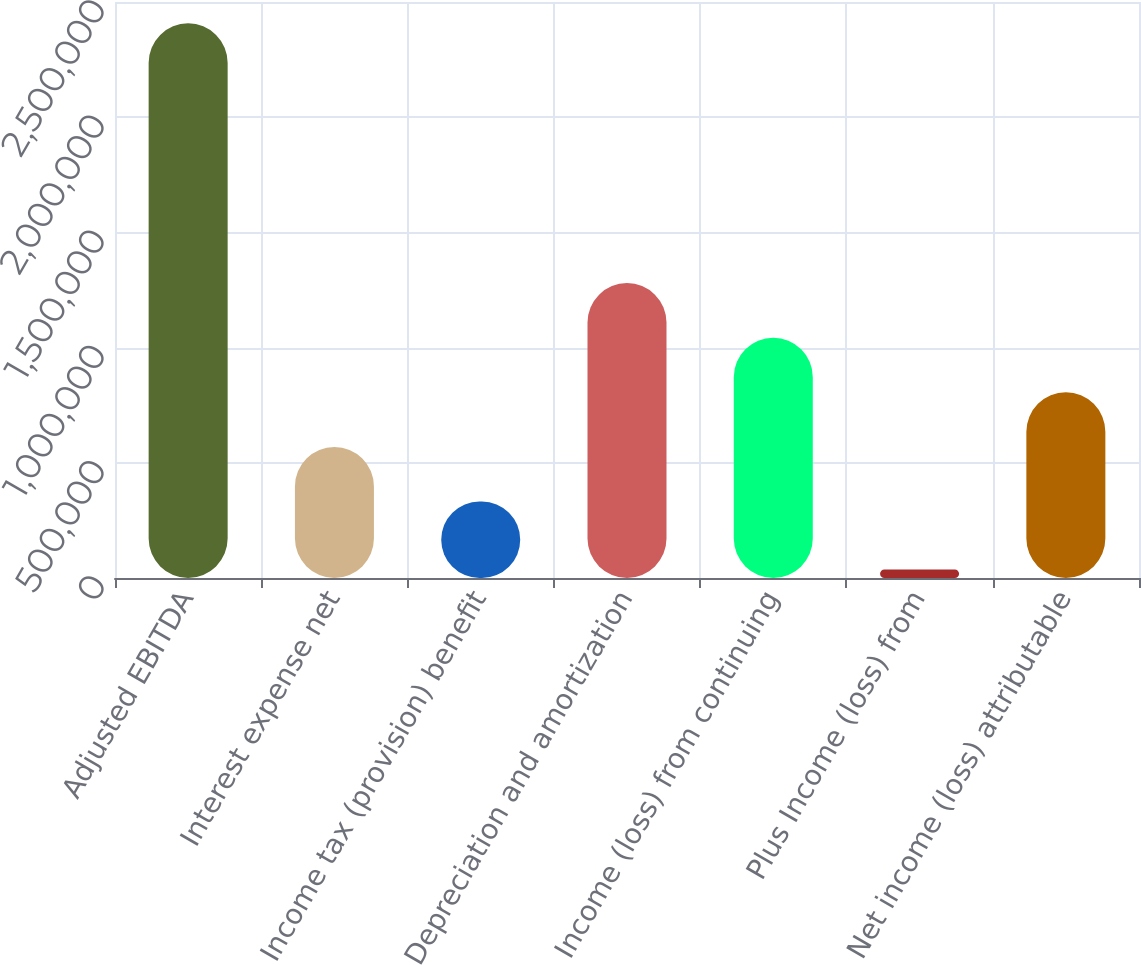<chart> <loc_0><loc_0><loc_500><loc_500><bar_chart><fcel>Adjusted EBITDA<fcel>Interest expense net<fcel>Income tax (provision) benefit<fcel>Depreciation and amortization<fcel>Income (loss) from continuing<fcel>Plus Income (loss) from<fcel>Net income (loss) attributable<nl><fcel>2.40749e+06<fcel>569022<fcel>331991<fcel>1.28011e+06<fcel>1.04308e+06<fcel>37179<fcel>806052<nl></chart> 